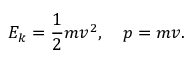<formula> <loc_0><loc_0><loc_500><loc_500>E _ { k } = { \frac { 1 } { 2 } } m v ^ { 2 } , \quad p = m v .</formula> 